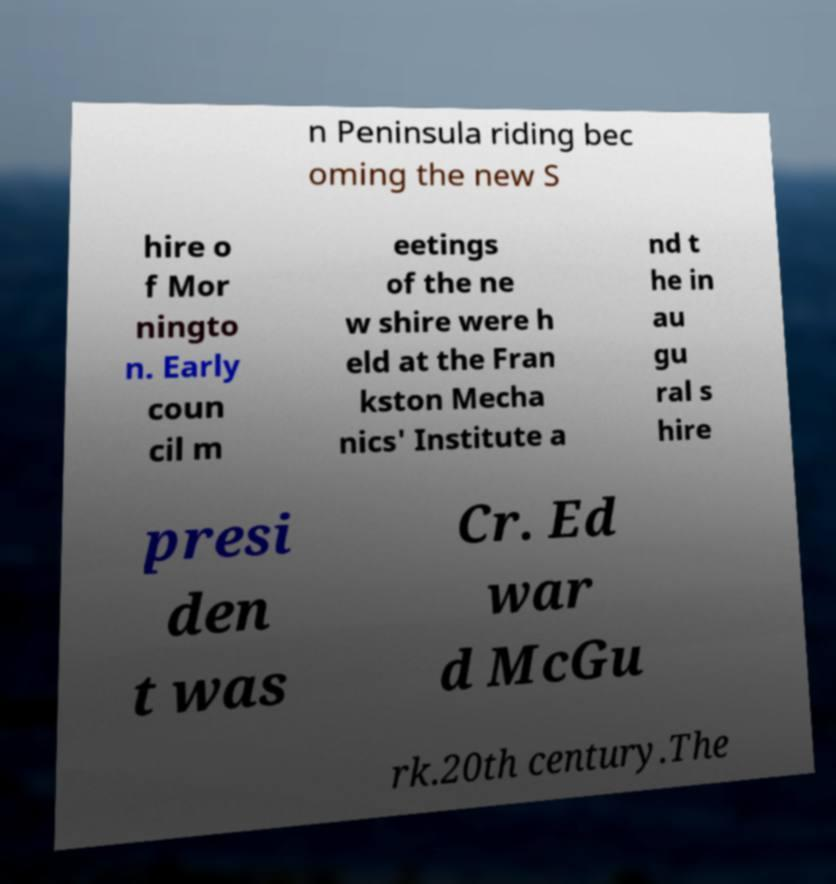There's text embedded in this image that I need extracted. Can you transcribe it verbatim? n Peninsula riding bec oming the new S hire o f Mor ningto n. Early coun cil m eetings of the ne w shire were h eld at the Fran kston Mecha nics' Institute a nd t he in au gu ral s hire presi den t was Cr. Ed war d McGu rk.20th century.The 